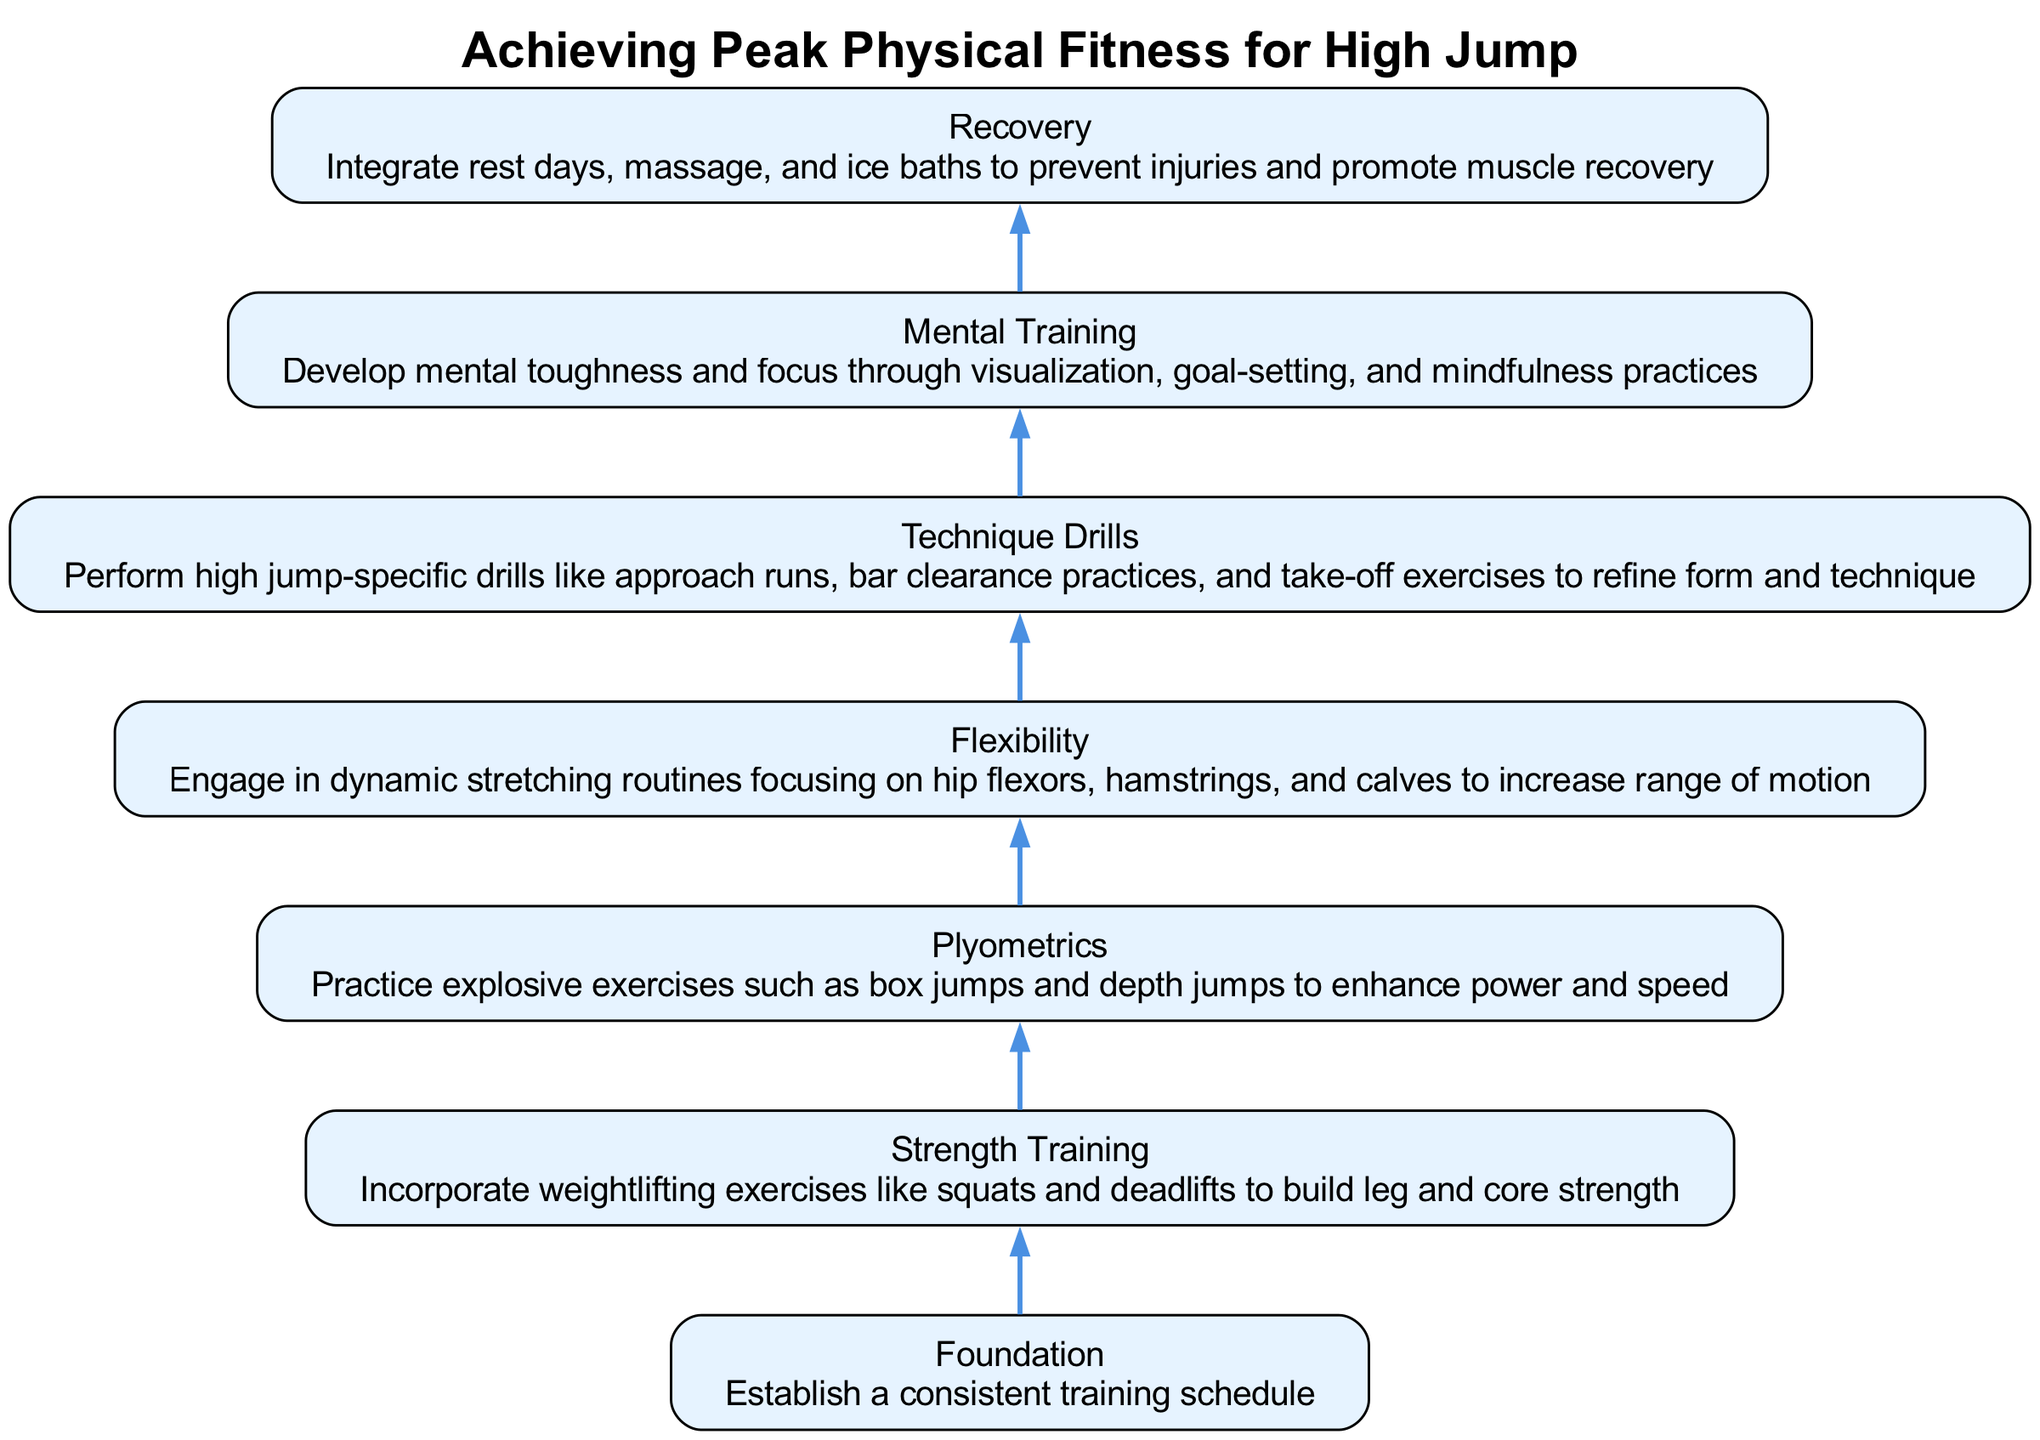What is the first step in achieving peak physical fitness for high jump? The diagram flows from the bottom to the top, and the first step at the bottom is labeled "Foundation," which emphasizes establishing a consistent training schedule.
Answer: Foundation How many total nodes are present in the diagram? Counting from the bottom to the top, there are a total of seven nodes that represent distinct steps in the process of achieving peak physical fitness for high jump.
Answer: 7 What exercise type is included to enhance power and speed? The diagram specifies "Plyometrics" in the third node, highlighting the importance of explosive exercises like box jumps and depth jumps for enhancing power and speed.
Answer: Plyometrics Which component comes before "Technique Drills"? Evaluating the flow from the bottom to the top, "Plyometrics" is the component that precedes "Technique Drills," making it the step that comes right before refining form and technique.
Answer: Plyometrics What is the purpose of the "Mental Training" node? The "Mental Training" node focuses on developing mental toughness and focus through visualization, goal-setting, and mindfulness practices, serving to enhance psychological readiness.
Answer: Develop mental toughness What is the connection between "Recovery" and "Strength Training"? In the diagram's flow, "Recovery" is the final step, while "Strength Training" is the second step from the bottom. They are connected through the overall training process, where strength training must be followed by recovery for optimal results.
Answer: Recovery follows Strength Training What kind of stretching is recommended to increase the range of motion? The "Flexibility" node specifically indicates engaging in dynamic stretching routines focusing on hip flexors, hamstrings, and calves to achieve a greater range of motion.
Answer: Dynamic stretching Which training element emphasizes injury prevention? The "Recovery" node incorporates rest days, massages, and ice baths to prevent injuries, highlighting its crucial role in maintaining overall fitness and injury prevention.
Answer: Recovery What is the overall message of the flow chart? The overarching message of the flow chart is to sequentially guide athletes through essential training components needed to reach peak physical fitness specifically tailored for high jump performance, starting with foundational elements to specialized drills.
Answer: Achieving Peak Physical Fitness 